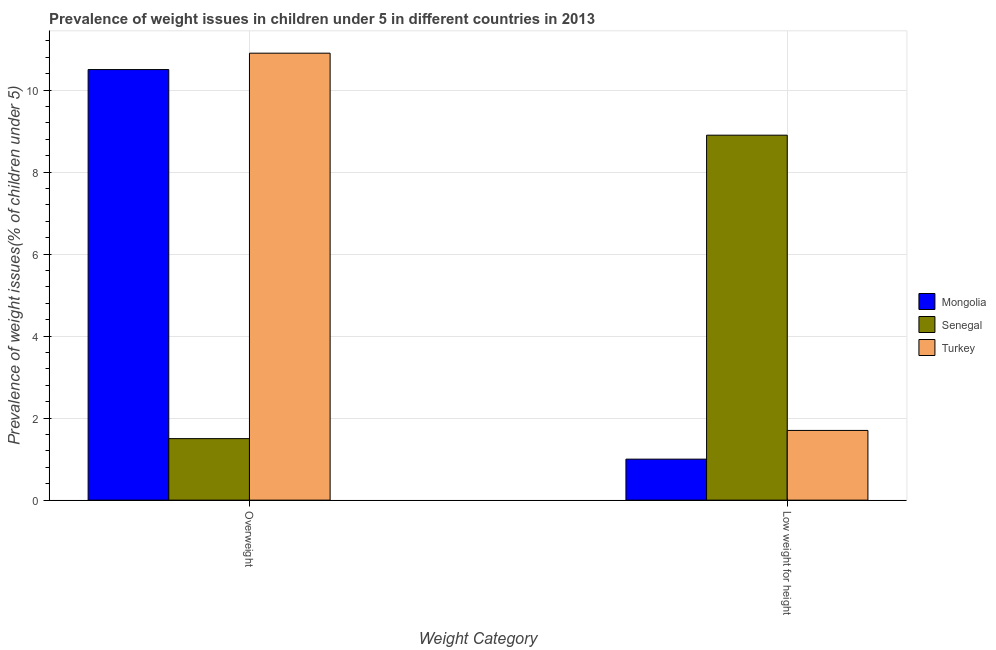How many groups of bars are there?
Keep it short and to the point. 2. Are the number of bars per tick equal to the number of legend labels?
Provide a succinct answer. Yes. How many bars are there on the 2nd tick from the left?
Your response must be concise. 3. What is the label of the 1st group of bars from the left?
Provide a succinct answer. Overweight. What is the percentage of underweight children in Turkey?
Your response must be concise. 1.7. Across all countries, what is the maximum percentage of underweight children?
Provide a succinct answer. 8.9. Across all countries, what is the minimum percentage of underweight children?
Your answer should be compact. 1. In which country was the percentage of overweight children maximum?
Provide a short and direct response. Turkey. In which country was the percentage of overweight children minimum?
Your answer should be very brief. Senegal. What is the total percentage of overweight children in the graph?
Ensure brevity in your answer.  22.9. What is the difference between the percentage of overweight children in Turkey and that in Senegal?
Your answer should be compact. 9.4. What is the difference between the percentage of overweight children in Senegal and the percentage of underweight children in Turkey?
Give a very brief answer. -0.2. What is the average percentage of underweight children per country?
Give a very brief answer. 3.87. What is the difference between the percentage of underweight children and percentage of overweight children in Senegal?
Provide a succinct answer. 7.4. What is the ratio of the percentage of underweight children in Turkey to that in Mongolia?
Offer a very short reply. 1.7. Is the percentage of underweight children in Turkey less than that in Mongolia?
Ensure brevity in your answer.  No. What does the 1st bar from the left in Low weight for height represents?
Your answer should be very brief. Mongolia. What does the 3rd bar from the right in Low weight for height represents?
Provide a short and direct response. Mongolia. How many bars are there?
Give a very brief answer. 6. Are all the bars in the graph horizontal?
Provide a succinct answer. No. What is the difference between two consecutive major ticks on the Y-axis?
Give a very brief answer. 2. Does the graph contain any zero values?
Your answer should be very brief. No. Where does the legend appear in the graph?
Provide a short and direct response. Center right. How many legend labels are there?
Your response must be concise. 3. How are the legend labels stacked?
Your response must be concise. Vertical. What is the title of the graph?
Offer a very short reply. Prevalence of weight issues in children under 5 in different countries in 2013. Does "Tanzania" appear as one of the legend labels in the graph?
Your response must be concise. No. What is the label or title of the X-axis?
Provide a short and direct response. Weight Category. What is the label or title of the Y-axis?
Give a very brief answer. Prevalence of weight issues(% of children under 5). What is the Prevalence of weight issues(% of children under 5) in Mongolia in Overweight?
Make the answer very short. 10.5. What is the Prevalence of weight issues(% of children under 5) of Senegal in Overweight?
Provide a short and direct response. 1.5. What is the Prevalence of weight issues(% of children under 5) in Turkey in Overweight?
Ensure brevity in your answer.  10.9. What is the Prevalence of weight issues(% of children under 5) of Senegal in Low weight for height?
Offer a terse response. 8.9. What is the Prevalence of weight issues(% of children under 5) in Turkey in Low weight for height?
Your answer should be very brief. 1.7. Across all Weight Category, what is the maximum Prevalence of weight issues(% of children under 5) in Senegal?
Give a very brief answer. 8.9. Across all Weight Category, what is the maximum Prevalence of weight issues(% of children under 5) of Turkey?
Your response must be concise. 10.9. Across all Weight Category, what is the minimum Prevalence of weight issues(% of children under 5) in Mongolia?
Provide a short and direct response. 1. Across all Weight Category, what is the minimum Prevalence of weight issues(% of children under 5) of Senegal?
Your response must be concise. 1.5. Across all Weight Category, what is the minimum Prevalence of weight issues(% of children under 5) in Turkey?
Offer a terse response. 1.7. What is the total Prevalence of weight issues(% of children under 5) of Mongolia in the graph?
Your answer should be compact. 11.5. What is the total Prevalence of weight issues(% of children under 5) in Senegal in the graph?
Keep it short and to the point. 10.4. What is the difference between the Prevalence of weight issues(% of children under 5) in Mongolia in Overweight and that in Low weight for height?
Your answer should be compact. 9.5. What is the difference between the Prevalence of weight issues(% of children under 5) in Mongolia in Overweight and the Prevalence of weight issues(% of children under 5) in Senegal in Low weight for height?
Your answer should be compact. 1.6. What is the difference between the Prevalence of weight issues(% of children under 5) in Mongolia in Overweight and the Prevalence of weight issues(% of children under 5) in Turkey in Low weight for height?
Your response must be concise. 8.8. What is the difference between the Prevalence of weight issues(% of children under 5) in Senegal in Overweight and the Prevalence of weight issues(% of children under 5) in Turkey in Low weight for height?
Keep it short and to the point. -0.2. What is the average Prevalence of weight issues(% of children under 5) in Mongolia per Weight Category?
Ensure brevity in your answer.  5.75. What is the average Prevalence of weight issues(% of children under 5) in Turkey per Weight Category?
Provide a short and direct response. 6.3. What is the difference between the Prevalence of weight issues(% of children under 5) of Mongolia and Prevalence of weight issues(% of children under 5) of Senegal in Overweight?
Offer a terse response. 9. What is the difference between the Prevalence of weight issues(% of children under 5) of Senegal and Prevalence of weight issues(% of children under 5) of Turkey in Overweight?
Offer a very short reply. -9.4. What is the difference between the Prevalence of weight issues(% of children under 5) in Mongolia and Prevalence of weight issues(% of children under 5) in Senegal in Low weight for height?
Offer a terse response. -7.9. What is the difference between the Prevalence of weight issues(% of children under 5) in Mongolia and Prevalence of weight issues(% of children under 5) in Turkey in Low weight for height?
Make the answer very short. -0.7. What is the ratio of the Prevalence of weight issues(% of children under 5) in Mongolia in Overweight to that in Low weight for height?
Offer a very short reply. 10.5. What is the ratio of the Prevalence of weight issues(% of children under 5) in Senegal in Overweight to that in Low weight for height?
Make the answer very short. 0.17. What is the ratio of the Prevalence of weight issues(% of children under 5) in Turkey in Overweight to that in Low weight for height?
Offer a very short reply. 6.41. What is the difference between the highest and the second highest Prevalence of weight issues(% of children under 5) in Mongolia?
Your answer should be very brief. 9.5. What is the difference between the highest and the second highest Prevalence of weight issues(% of children under 5) of Senegal?
Provide a succinct answer. 7.4. What is the difference between the highest and the second highest Prevalence of weight issues(% of children under 5) of Turkey?
Your answer should be very brief. 9.2. What is the difference between the highest and the lowest Prevalence of weight issues(% of children under 5) in Senegal?
Offer a terse response. 7.4. 